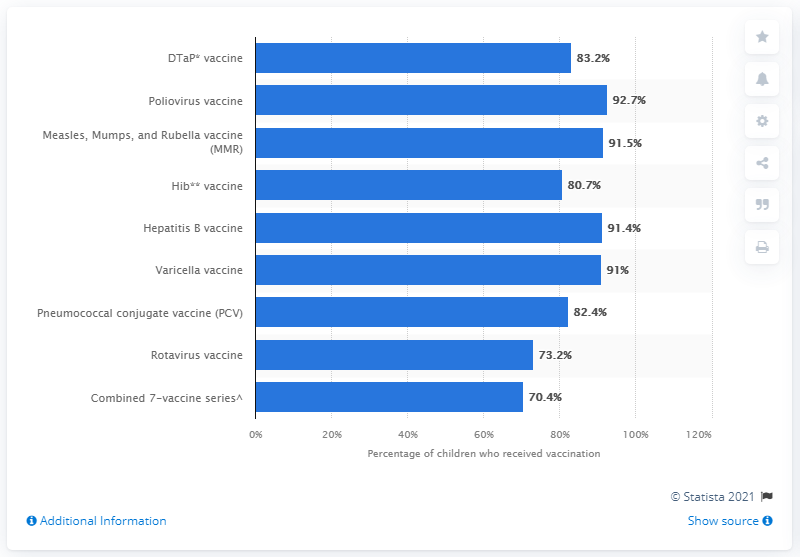Mention a couple of crucial points in this snapshot. The poliovirus vaccine has achieved a 92.7% effectiveness rate. The value of the longest bar is 93. 